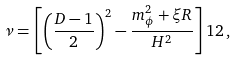<formula> <loc_0><loc_0><loc_500><loc_500>\nu = \left [ \left ( \frac { D - 1 } { 2 } \right ) ^ { 2 } - \frac { m _ { \phi } ^ { 2 } + \xi R } { H ^ { 2 } } \right ] ^ { } { 1 } 2 \, ,</formula> 